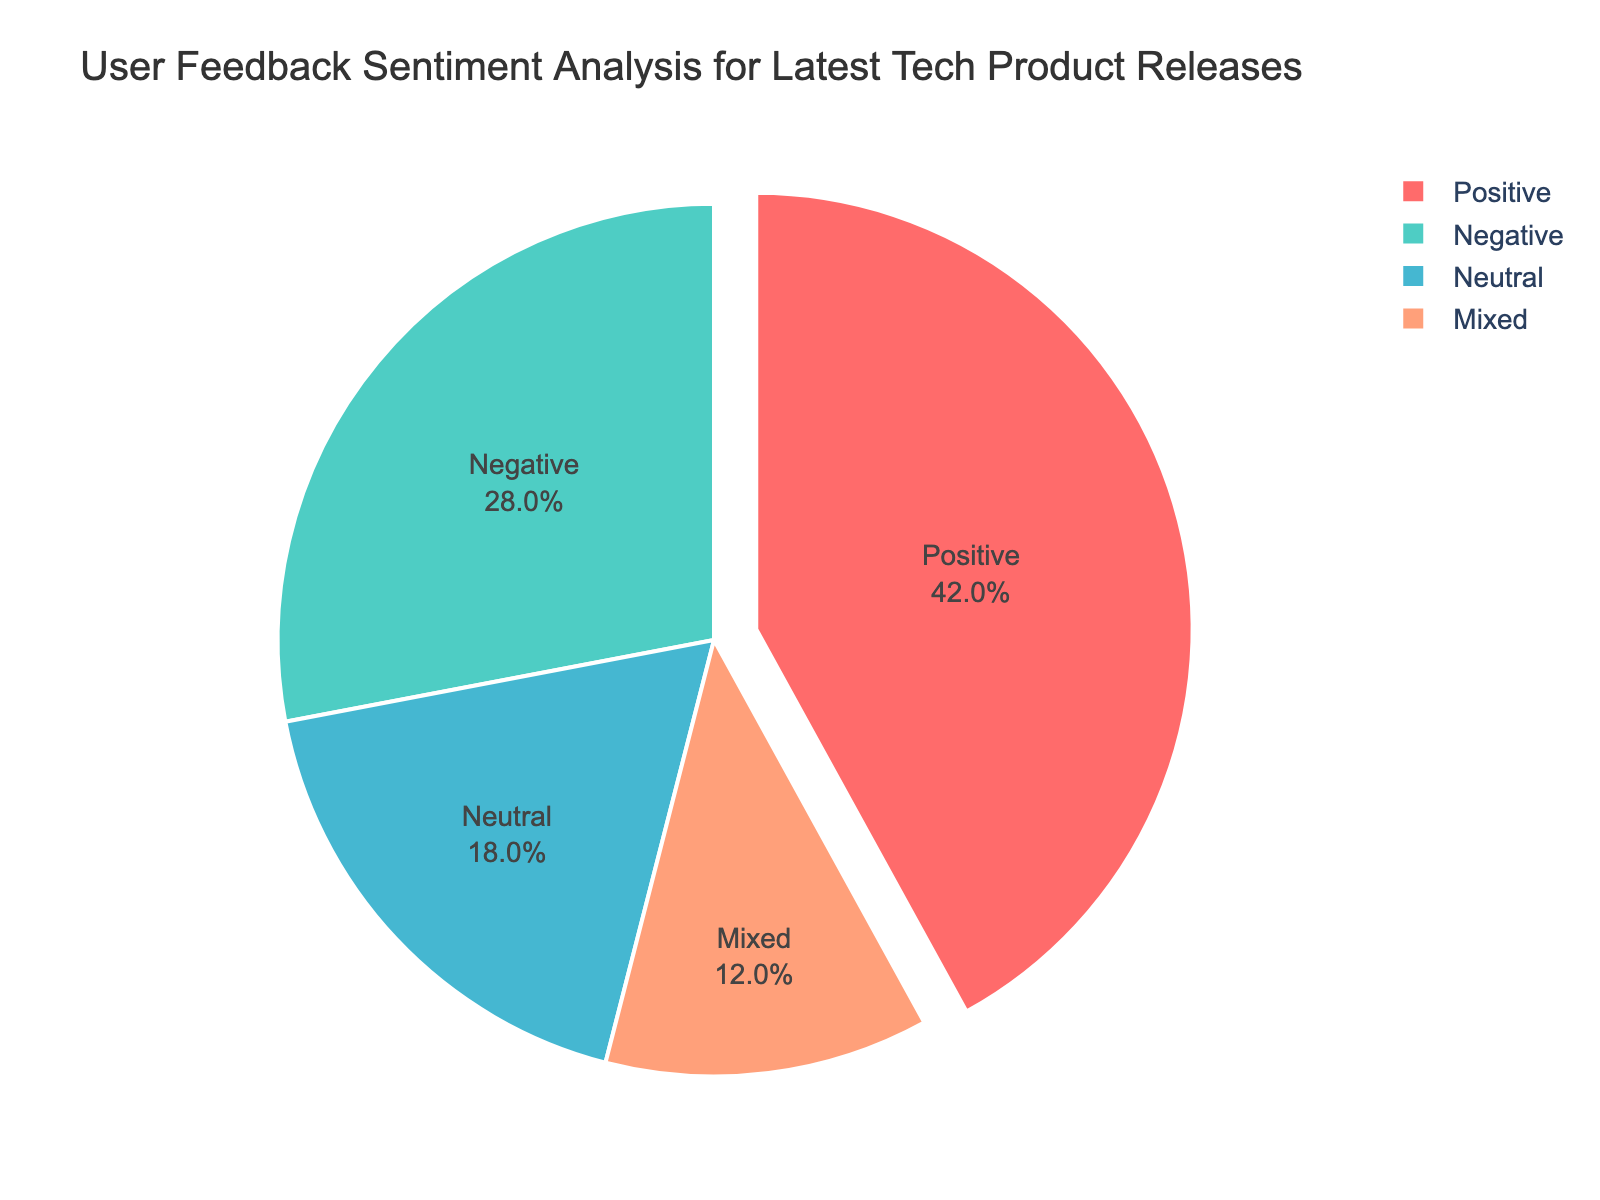What's the ratio of positive feedback to negative feedback? To find the ratio of positive feedback to negative feedback, take the percentage of positive feedback (42%) and divide it by the percentage of negative feedback (28%). The ratio is 42:28, which simplifies to 3:2.
Answer: 3:2 What is the total percentage of non-positive feedback? Non-positive feedback includes negative (28%), neutral (18%), and mixed (12%) sentiments. Sum these percentages: 28 + 18 + 12 = 58%.
Answer: 58% Which sentiment category is represented by the largest slice of the pie chart? The largest slice of the pie chart corresponds to the sentiment with the highest percentage. According to the provided data, positive sentiment has the highest percentage at 42%.
Answer: Positive Is the percentage of neutral feedback greater than the percentage of mixed feedback? Comparing the percentages, neutral feedback is 18% and mixed feedback is 12%. Since 18% is greater than 12%, neutral feedback has a higher percentage.
Answer: Yes By what percentage is positive feedback greater than mixed feedback? Subtract the percentage of mixed feedback (12%) from the percentage of positive feedback (42%): 42 - 12 = 30%. Positive feedback is 30% greater than mixed feedback.
Answer: 30% What is the difference between the percentages of positive and negative feedback? Subtract the percentage of negative feedback (28%) from the percentage of positive feedback (42%): 42 - 28 = 14%.
Answer: 14% 